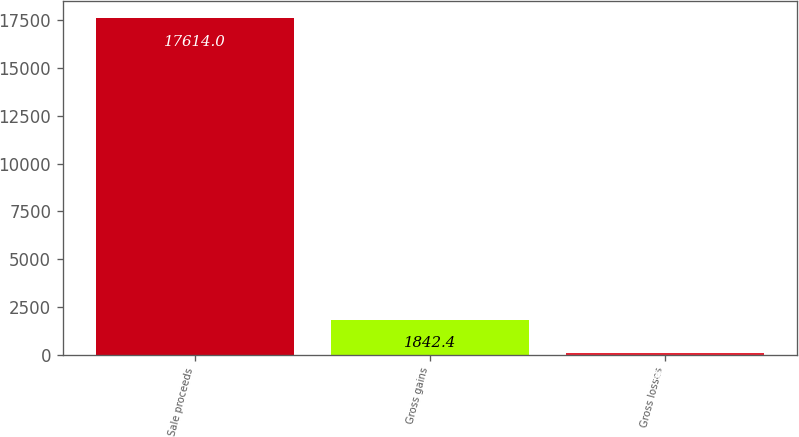Convert chart. <chart><loc_0><loc_0><loc_500><loc_500><bar_chart><fcel>Sale proceeds<fcel>Gross gains<fcel>Gross losses<nl><fcel>17614<fcel>1842.4<fcel>90<nl></chart> 